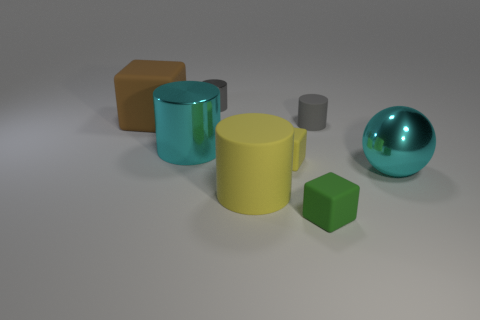Subtract all big cyan cylinders. How many cylinders are left? 3 Add 2 big cyan spheres. How many objects exist? 10 Subtract all cyan cylinders. How many cylinders are left? 3 Subtract 1 cylinders. How many cylinders are left? 3 Subtract 0 brown spheres. How many objects are left? 8 Subtract all blocks. How many objects are left? 5 Subtract all blue blocks. Subtract all blue balls. How many blocks are left? 3 Subtract all purple cubes. How many gray balls are left? 0 Subtract all tiny brown shiny things. Subtract all matte objects. How many objects are left? 3 Add 6 small gray matte cylinders. How many small gray matte cylinders are left? 7 